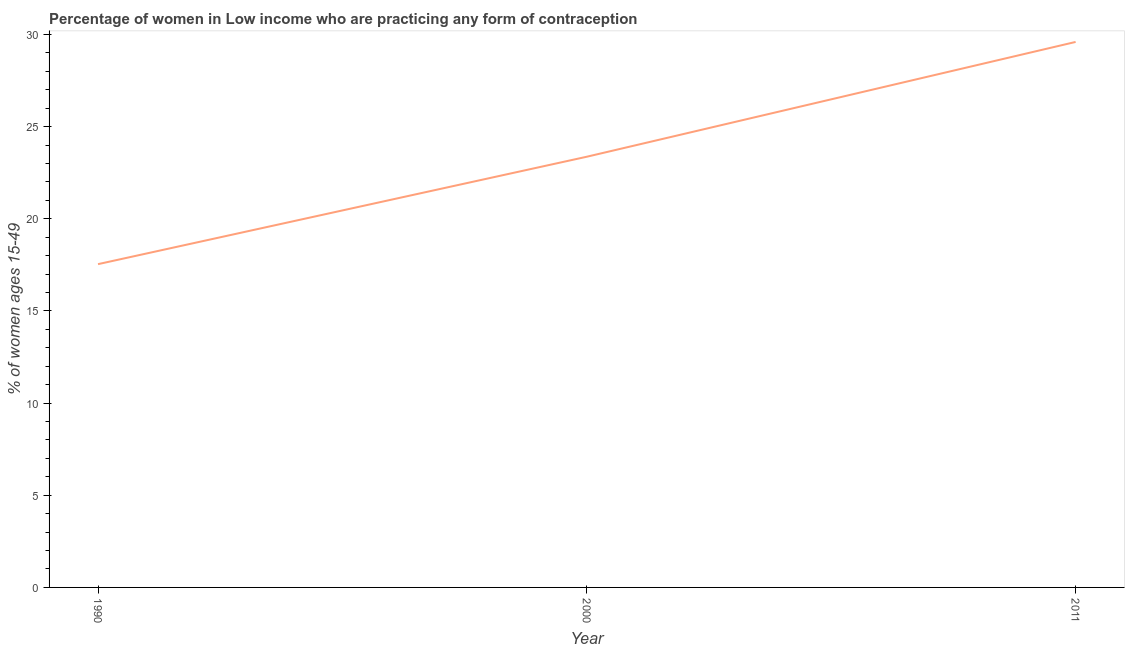What is the contraceptive prevalence in 2000?
Keep it short and to the point. 23.37. Across all years, what is the maximum contraceptive prevalence?
Offer a very short reply. 29.6. Across all years, what is the minimum contraceptive prevalence?
Make the answer very short. 17.54. In which year was the contraceptive prevalence maximum?
Provide a short and direct response. 2011. In which year was the contraceptive prevalence minimum?
Your response must be concise. 1990. What is the sum of the contraceptive prevalence?
Offer a very short reply. 70.51. What is the difference between the contraceptive prevalence in 2000 and 2011?
Give a very brief answer. -6.23. What is the average contraceptive prevalence per year?
Provide a succinct answer. 23.5. What is the median contraceptive prevalence?
Make the answer very short. 23.37. Do a majority of the years between 2011 and 2000 (inclusive) have contraceptive prevalence greater than 14 %?
Your response must be concise. No. What is the ratio of the contraceptive prevalence in 2000 to that in 2011?
Keep it short and to the point. 0.79. Is the contraceptive prevalence in 1990 less than that in 2000?
Offer a very short reply. Yes. Is the difference between the contraceptive prevalence in 2000 and 2011 greater than the difference between any two years?
Provide a short and direct response. No. What is the difference between the highest and the second highest contraceptive prevalence?
Your response must be concise. 6.23. What is the difference between the highest and the lowest contraceptive prevalence?
Offer a very short reply. 12.06. In how many years, is the contraceptive prevalence greater than the average contraceptive prevalence taken over all years?
Offer a terse response. 1. Does the contraceptive prevalence monotonically increase over the years?
Ensure brevity in your answer.  Yes. How many lines are there?
Offer a very short reply. 1. What is the title of the graph?
Provide a succinct answer. Percentage of women in Low income who are practicing any form of contraception. What is the label or title of the X-axis?
Keep it short and to the point. Year. What is the label or title of the Y-axis?
Your answer should be compact. % of women ages 15-49. What is the % of women ages 15-49 of 1990?
Make the answer very short. 17.54. What is the % of women ages 15-49 in 2000?
Your response must be concise. 23.37. What is the % of women ages 15-49 in 2011?
Provide a short and direct response. 29.6. What is the difference between the % of women ages 15-49 in 1990 and 2000?
Give a very brief answer. -5.83. What is the difference between the % of women ages 15-49 in 1990 and 2011?
Provide a succinct answer. -12.06. What is the difference between the % of women ages 15-49 in 2000 and 2011?
Ensure brevity in your answer.  -6.23. What is the ratio of the % of women ages 15-49 in 1990 to that in 2000?
Offer a very short reply. 0.75. What is the ratio of the % of women ages 15-49 in 1990 to that in 2011?
Give a very brief answer. 0.59. What is the ratio of the % of women ages 15-49 in 2000 to that in 2011?
Your answer should be very brief. 0.79. 